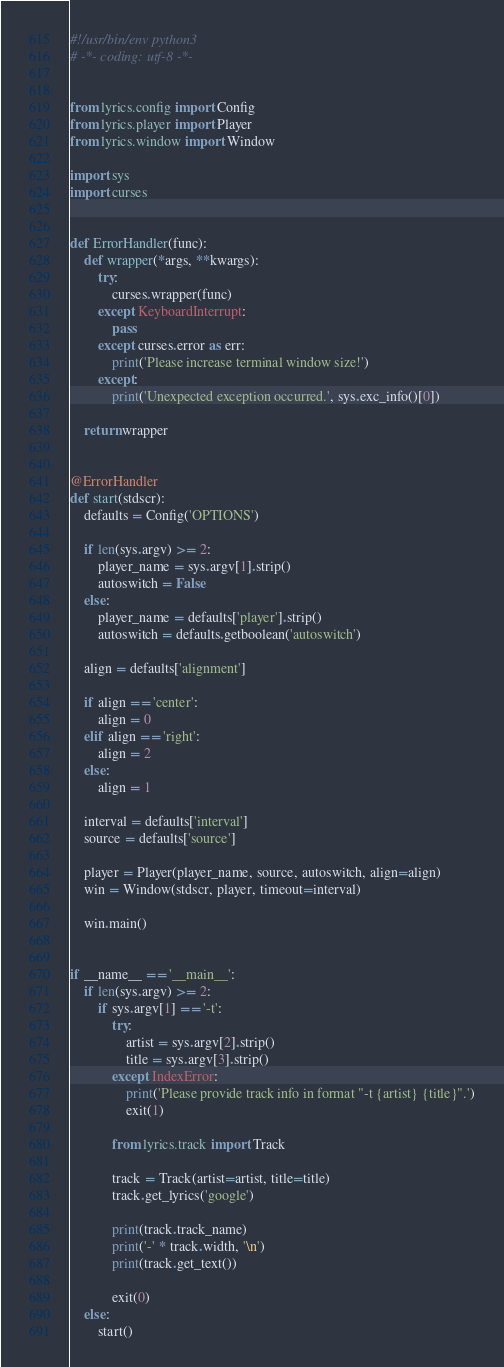Convert code to text. <code><loc_0><loc_0><loc_500><loc_500><_Python_>#!/usr/bin/env python3
# -*- coding: utf-8 -*-


from lyrics.config import Config
from lyrics.player import Player
from lyrics.window import Window

import sys
import curses


def ErrorHandler(func):
    def wrapper(*args, **kwargs):
        try:
            curses.wrapper(func)
        except KeyboardInterrupt:
            pass
        except curses.error as err:
            print('Please increase terminal window size!')
        except:
            print('Unexpected exception occurred.', sys.exc_info()[0])

    return wrapper


@ErrorHandler
def start(stdscr):
    defaults = Config('OPTIONS')

    if len(sys.argv) >= 2:
        player_name = sys.argv[1].strip()
        autoswitch = False
    else:
        player_name = defaults['player'].strip()
        autoswitch = defaults.getboolean('autoswitch')

    align = defaults['alignment']

    if align == 'center':
        align = 0
    elif align == 'right':
        align = 2
    else:
        align = 1

    interval = defaults['interval']
    source = defaults['source']

    player = Player(player_name, source, autoswitch, align=align)
    win = Window(stdscr, player, timeout=interval)

    win.main()


if __name__ == '__main__':
    if len(sys.argv) >= 2:
        if sys.argv[1] == '-t':
            try:
                artist = sys.argv[2].strip()
                title = sys.argv[3].strip()
            except IndexError:
                print('Please provide track info in format "-t {artist} {title}".')
                exit(1)

            from lyrics.track import Track

            track = Track(artist=artist, title=title)
            track.get_lyrics('google')

            print(track.track_name)
            print('-' * track.width, '\n')
            print(track.get_text())

            exit(0)
    else:
        start()

</code> 